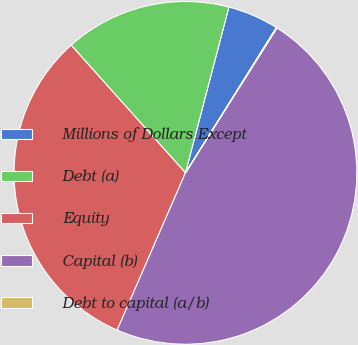Convert chart to OTSL. <chart><loc_0><loc_0><loc_500><loc_500><pie_chart><fcel>Millions of Dollars Except<fcel>Debt (a)<fcel>Equity<fcel>Capital (b)<fcel>Debt to capital (a/b)<nl><fcel>4.82%<fcel>15.7%<fcel>31.86%<fcel>47.56%<fcel>0.07%<nl></chart> 